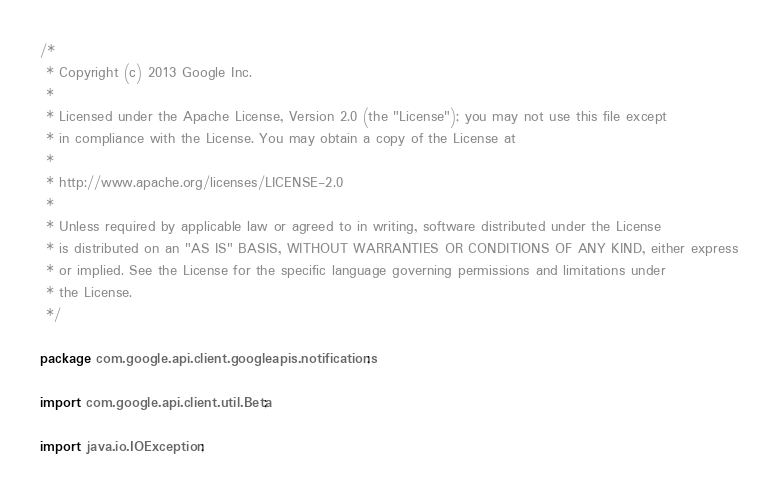Convert code to text. <code><loc_0><loc_0><loc_500><loc_500><_Java_>/*
 * Copyright (c) 2013 Google Inc.
 *
 * Licensed under the Apache License, Version 2.0 (the "License"); you may not use this file except
 * in compliance with the License. You may obtain a copy of the License at
 *
 * http://www.apache.org/licenses/LICENSE-2.0
 *
 * Unless required by applicable law or agreed to in writing, software distributed under the License
 * is distributed on an "AS IS" BASIS, WITHOUT WARRANTIES OR CONDITIONS OF ANY KIND, either express
 * or implied. See the License for the specific language governing permissions and limitations under
 * the License.
 */

package com.google.api.client.googleapis.notifications;

import com.google.api.client.util.Beta;

import java.io.IOException;</code> 